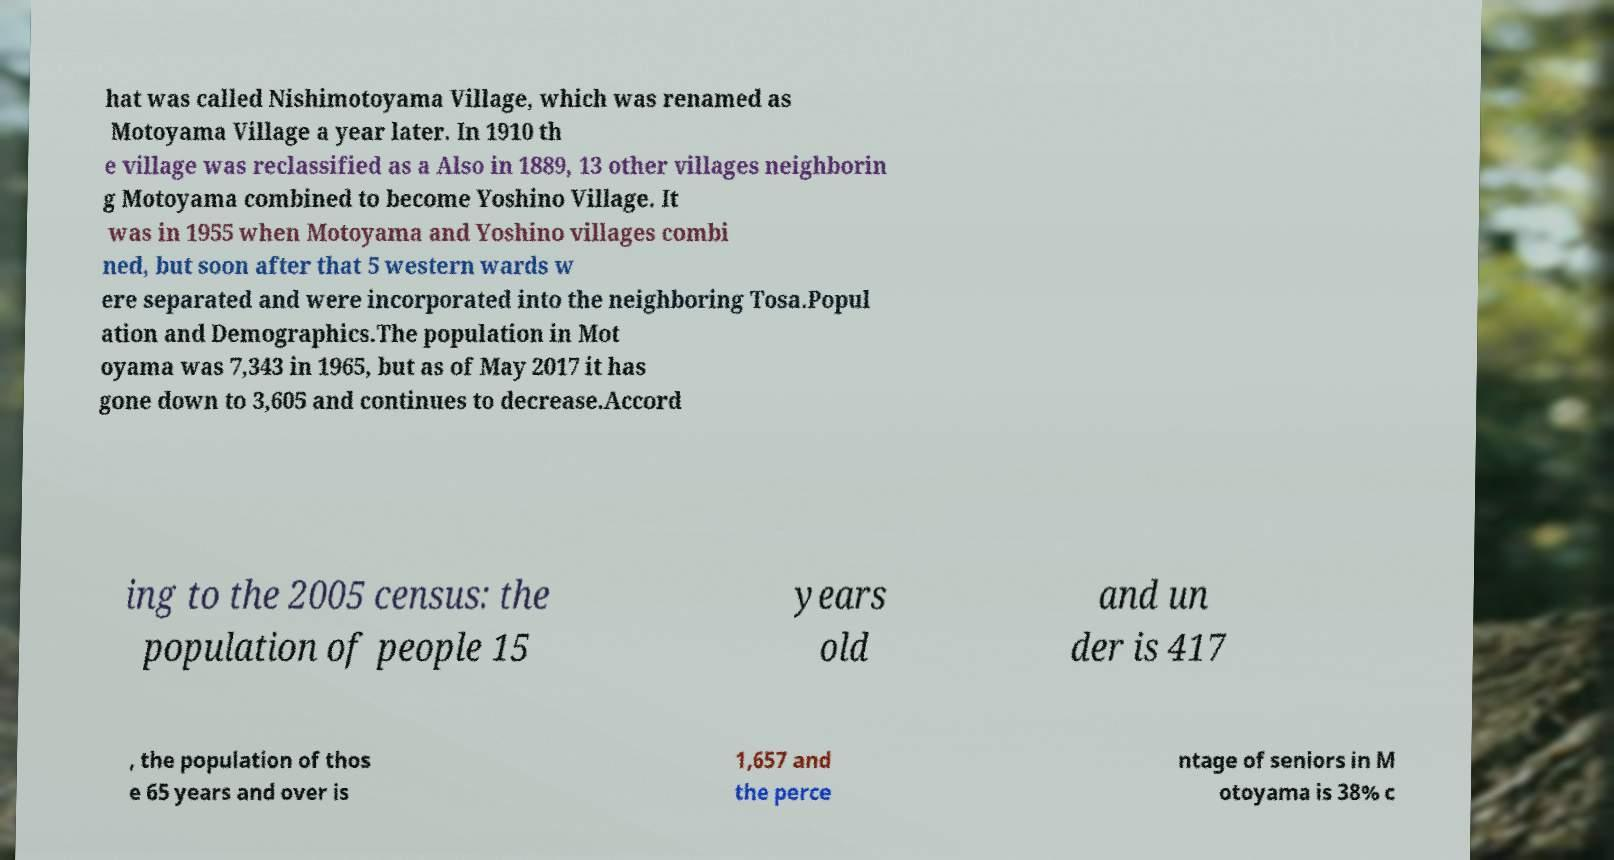Could you assist in decoding the text presented in this image and type it out clearly? hat was called Nishimotoyama Village, which was renamed as Motoyama Village a year later. In 1910 th e village was reclassified as a Also in 1889, 13 other villages neighborin g Motoyama combined to become Yoshino Village. It was in 1955 when Motoyama and Yoshino villages combi ned, but soon after that 5 western wards w ere separated and were incorporated into the neighboring Tosa.Popul ation and Demographics.The population in Mot oyama was 7,343 in 1965, but as of May 2017 it has gone down to 3‚605 and continues to decrease.Accord ing to the 2005 census: the population of people 15 years old and un der is 417 , the population of thos e 65 years and over is 1,657 and the perce ntage of seniors in M otoyama is 38% c 